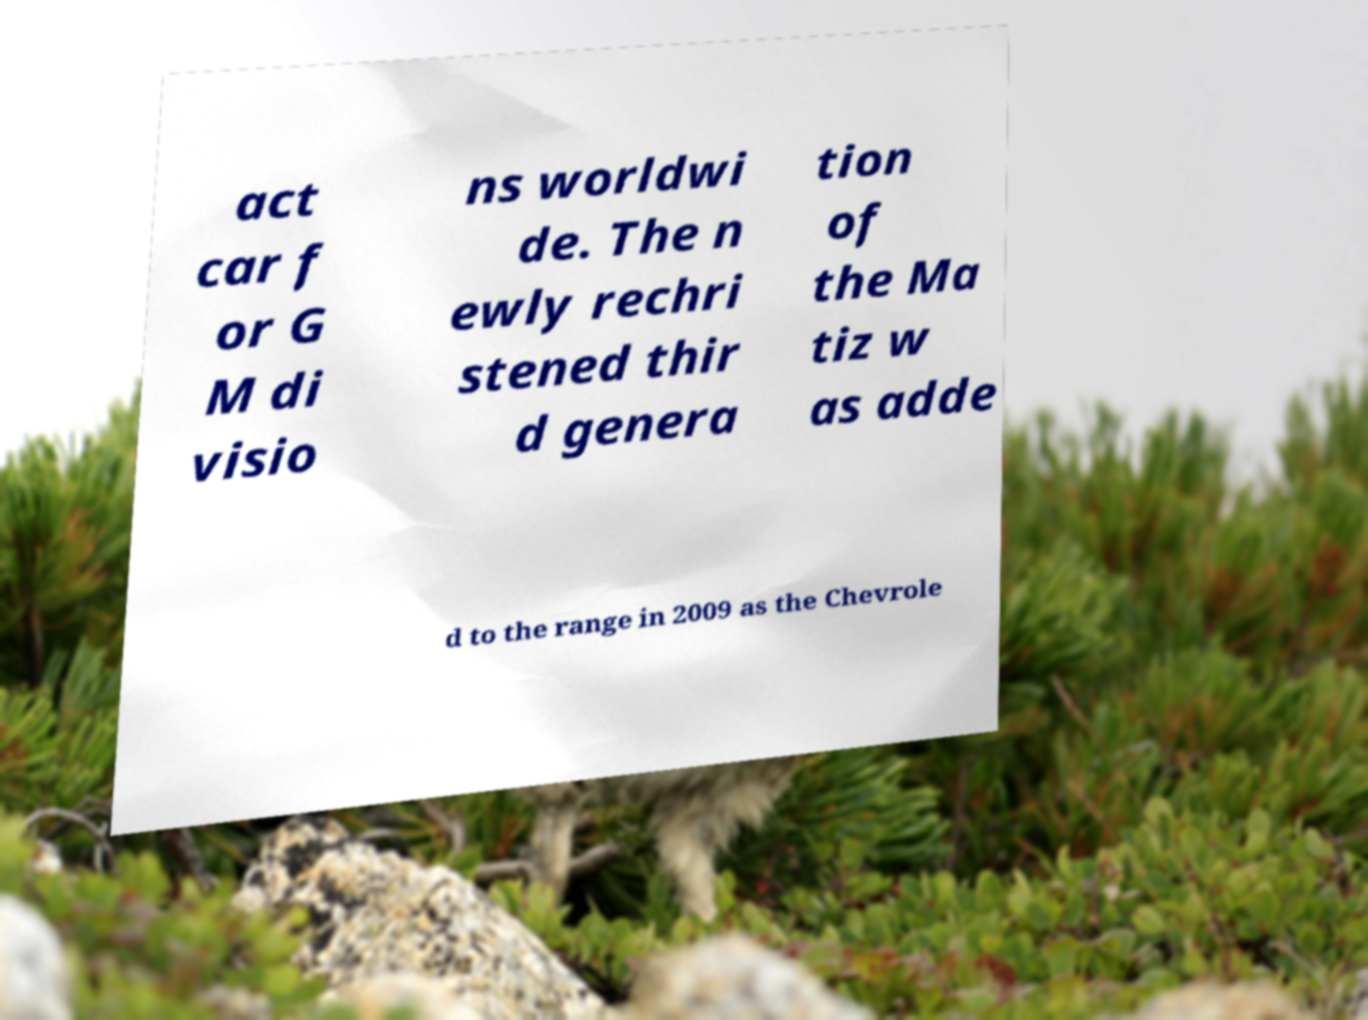Could you assist in decoding the text presented in this image and type it out clearly? act car f or G M di visio ns worldwi de. The n ewly rechri stened thir d genera tion of the Ma tiz w as adde d to the range in 2009 as the Chevrole 